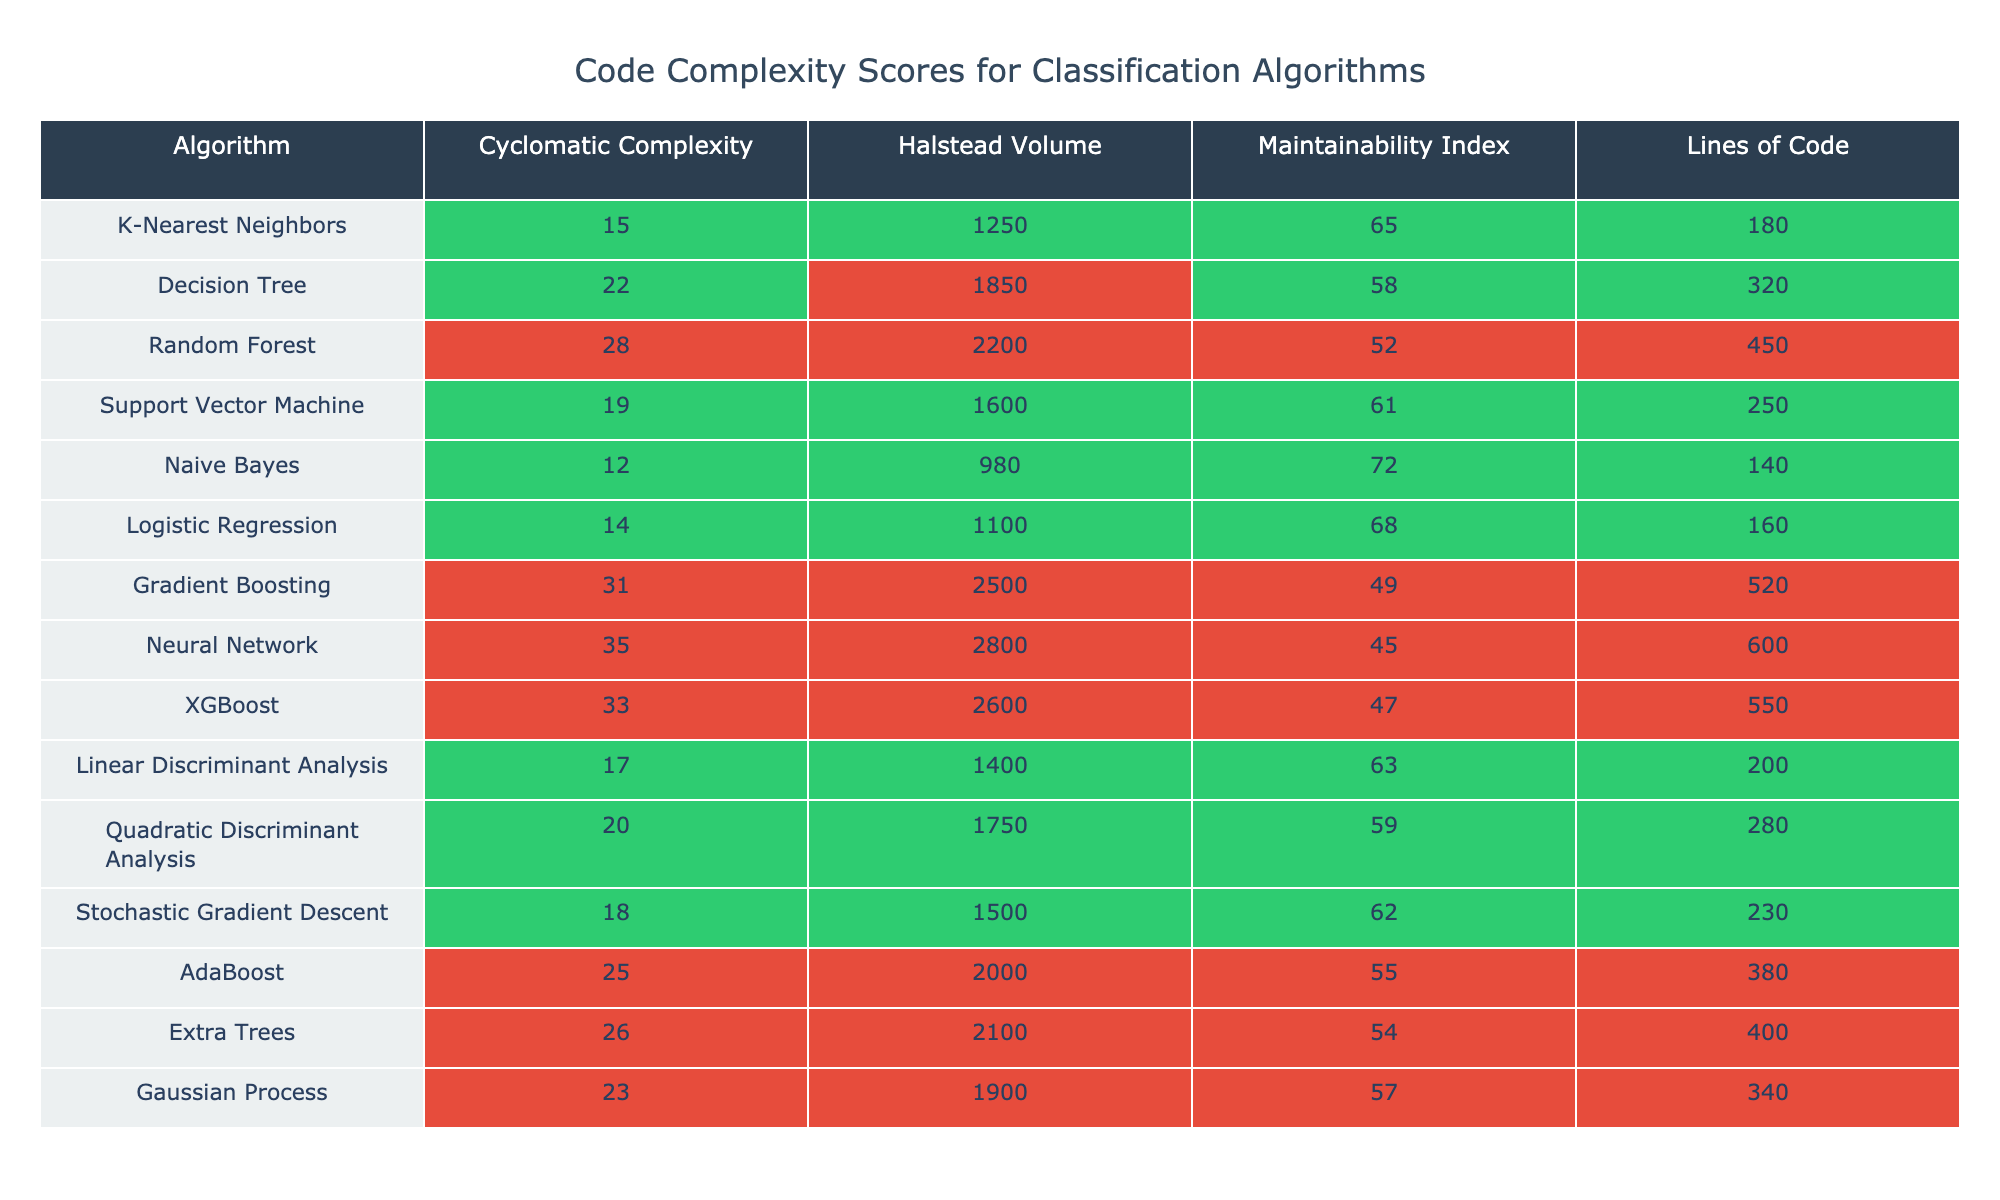What is the cyclomatic complexity of the Neural Network algorithm? The cyclomatic complexity for Neural Network is listed in the table under the corresponding column, which shows the value as 35.
Answer: 35 Which algorithm has the highest Halstead Volume? The Halstead Volume column indicates that Neural Network, with a volume of 2800, is the highest among all algorithms.
Answer: Neural Network What is the maintainability index of the algorithm with the lowest Lines of Code? The algorithm with the lowest Lines of Code is Naive Bayes, which has a maintainability index of 72, found in the corresponding column.
Answer: 72 Calculate the average cyclomatic complexity of all algorithms. The cyclomatic complexities of all algorithms are 15, 22, 28, 19, 12, 14, 31, 35, 33, 17, 20, 18, 25, 26, and 23. The total sum is  15 + 22 + 28 + 19 + 12 + 14 + 31 + 35 + 33 + 17 + 20 + 18 + 25 + 26 + 23 =  392. There are 15 algorithms, so the average is 392/15 ≈ 26.13.
Answer: 26.13 Which algorithm has the second highest Maintainability Index, and what is its value? The Maintainability Index values, when sorted, show that Logistic Regression has the second highest index of 68, following Naive Bayes which has 72.
Answer: Logistic Regression, 68 Is the Halstead Volume of Gradient Boosting greater than that of Random Forest? The Halstead Volume for Gradient Boosting is 2500, while for Random Forest, it is 2200. Since 2500 is greater than 2200, the statement is true.
Answer: Yes What is the difference in Lines of Code between the top and bottom algorithms based on the complexity scores? The algorithm with the highest Lines of Code is Neural Network with 600, and the one with the lowest is Naive Bayes with 140. The difference is 600 - 140 = 460.
Answer: 460 How many algorithms have a Maintainability Index below 60? The algorithms with Maintainability Indexes below 60 are Random Forest (52), Gradient Boosting (49), and Neural Network (45). Therefore, there are three algorithms that meet this criterion.
Answer: 3 Is there any algorithm that has both a Cyclomatic Complexity and a maintainability index above the average of their categories? The average cyclomatic complexity is approximately 26.13, while the average maintainability index is approximately 58.67. Looking at the table, both Gradient Boosting (Cyclomatic Complexity 31, Maintainability Index 49) and Neural Network (Cyclomatic Complexity 35, Maintainability Index 45) fall below the average in maintainability. Thus, no algorithms meet the criteria.
Answer: No 